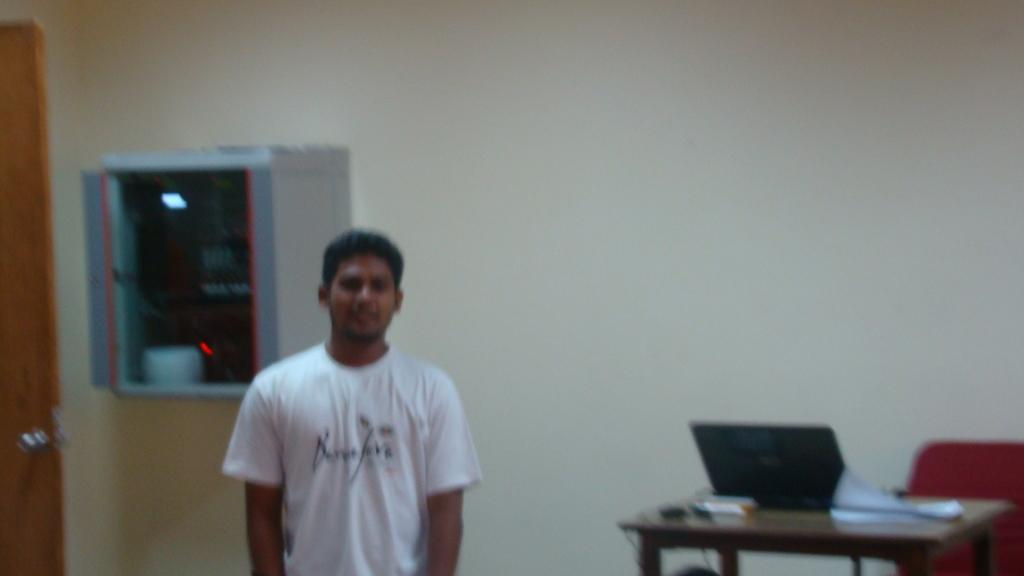What is the color of the wall in the image? The wall in the image is white. Who is present in the image? There is a man standing in the image. What objects are on the right side of the image? There is a table and a chair on the right side of the image. What device is on the table in the image? There is a laptop on the table in the image. How many sisters are sitting on the chair in the image? There are no sisters present in the image; only a man is visible. Are there any giants visible in the image? There are no giants present in the image. 